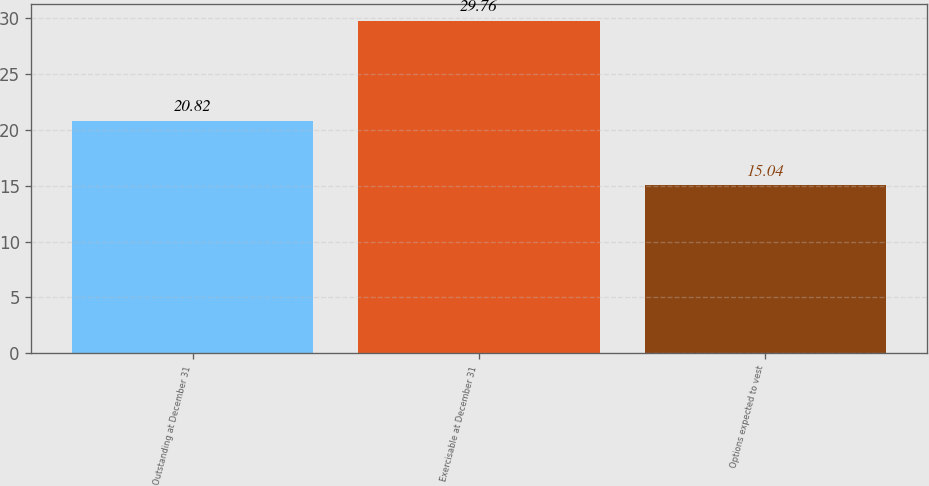Convert chart. <chart><loc_0><loc_0><loc_500><loc_500><bar_chart><fcel>Outstanding at December 31<fcel>Exercisable at December 31<fcel>Options expected to vest<nl><fcel>20.82<fcel>29.76<fcel>15.04<nl></chart> 